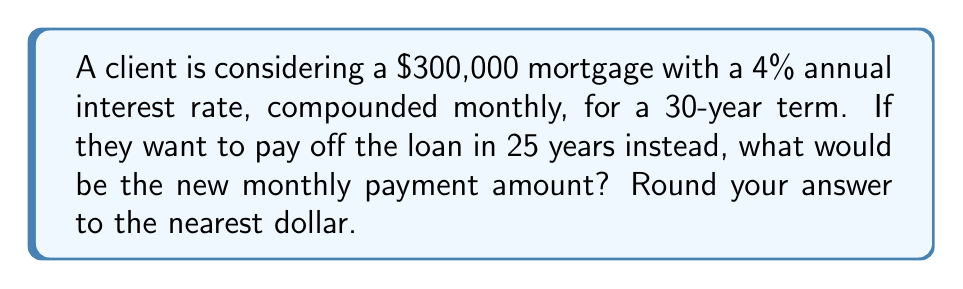What is the answer to this math problem? Let's approach this step-by-step:

1. First, let's calculate the original monthly payment for the 30-year term:
   - Principal (P) = $300,000
   - Annual interest rate (r) = 4% = 0.04
   - Monthly interest rate (i) = 0.04 / 12 = 0.0033333
   - Number of payments (n) = 30 years * 12 months = 360

   Using the mortgage payment formula:
   $$ \text{Payment} = P \cdot \frac{i(1+i)^n}{(1+i)^n - 1} $$

   $$ \text{Payment} = 300000 \cdot \frac{0.0033333(1+0.0033333)^{360}}{(1+0.0033333)^{360} - 1} $$

   $$ \text{Payment} \approx $1,432.25 $$

2. Now, let's calculate the new monthly payment for the 25-year term:
   - Principal (P) = $300,000
   - Monthly interest rate (i) = 0.0033333
   - Number of payments (n) = 25 years * 12 months = 300

   Using the same formula:

   $$ \text{Payment} = 300000 \cdot \frac{0.0033333(1+0.0033333)^{300}}{(1+0.0033333)^{300} - 1} $$

   $$ \text{Payment} \approx $1,584.07 $$

3. Rounding to the nearest dollar:
   $1,584.07 ≈ $1,584
Answer: $1,584 